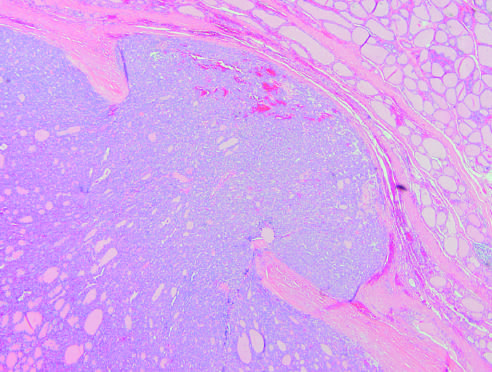what demonstrate capsular invasion that may be minimal, as in this case, or widespread, with extension into local structures of the neck by contrast?
Answer the question using a single word or phrase. Follicular carcinomas 